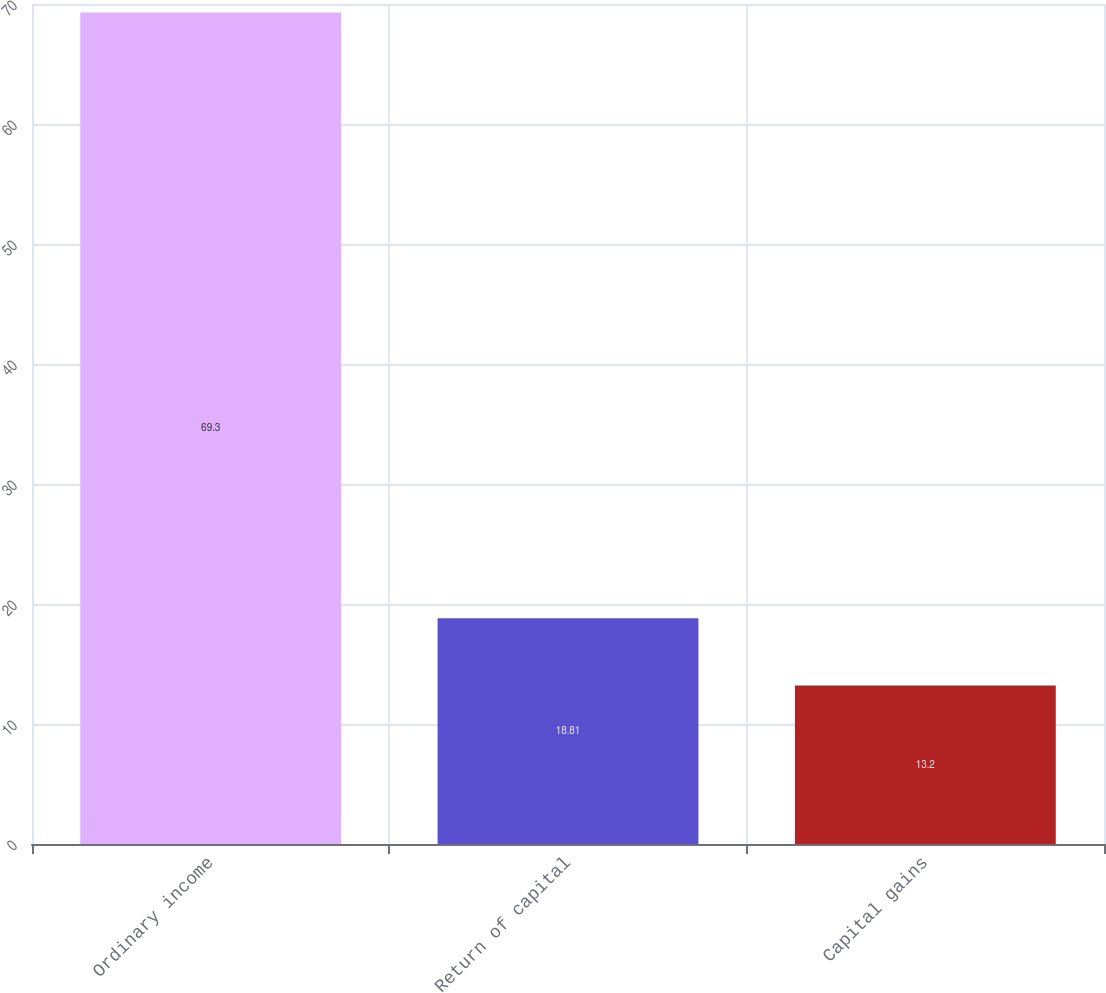<chart> <loc_0><loc_0><loc_500><loc_500><bar_chart><fcel>Ordinary income<fcel>Return of capital<fcel>Capital gains<nl><fcel>69.3<fcel>18.81<fcel>13.2<nl></chart> 